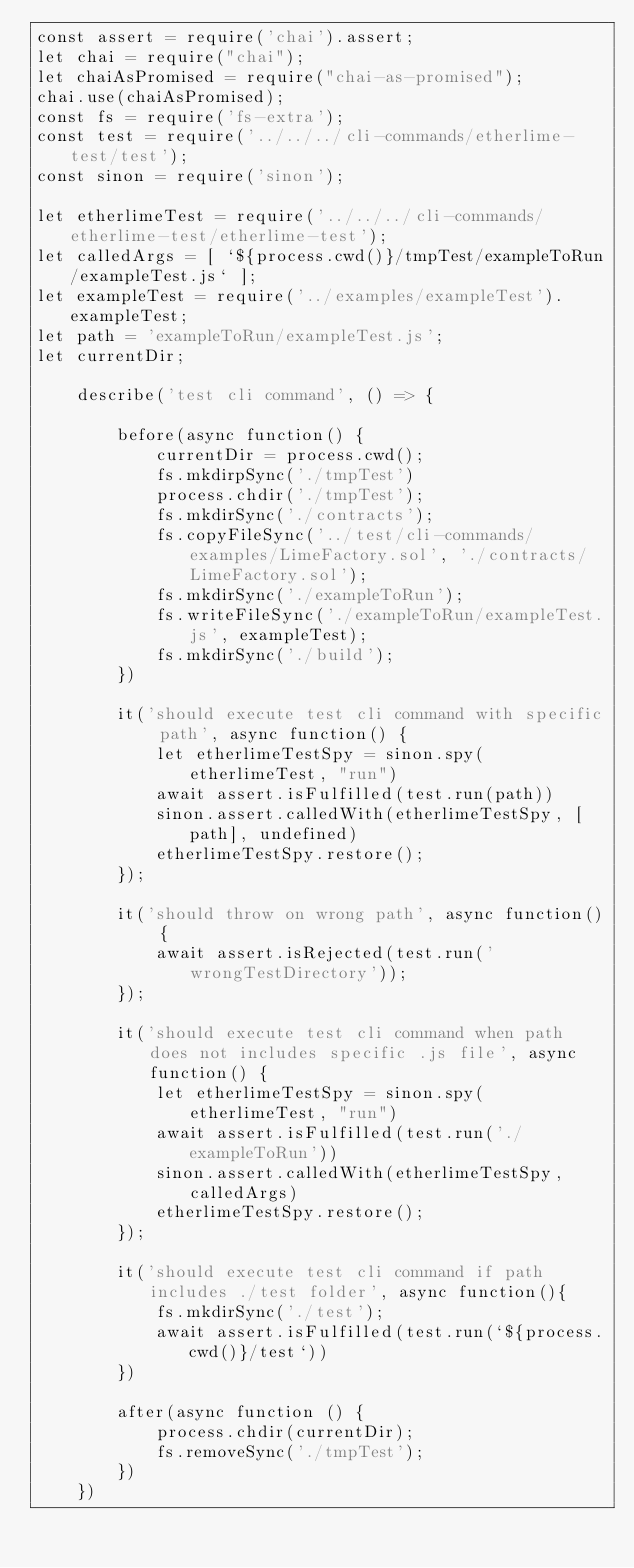<code> <loc_0><loc_0><loc_500><loc_500><_JavaScript_>const assert = require('chai').assert;
let chai = require("chai");
let chaiAsPromised = require("chai-as-promised");
chai.use(chaiAsPromised);
const fs = require('fs-extra');
const test = require('../../../cli-commands/etherlime-test/test');
const sinon = require('sinon');

let etherlimeTest = require('../../../cli-commands/etherlime-test/etherlime-test');
let calledArgs = [ `${process.cwd()}/tmpTest/exampleToRun/exampleTest.js` ];
let exampleTest = require('../examples/exampleTest').exampleTest;
let path = 'exampleToRun/exampleTest.js';
let currentDir;

    describe('test cli command', () => {

        before(async function() {
            currentDir = process.cwd();
            fs.mkdirpSync('./tmpTest')
            process.chdir('./tmpTest');
            fs.mkdirSync('./contracts');
            fs.copyFileSync('../test/cli-commands/examples/LimeFactory.sol', './contracts/LimeFactory.sol');
            fs.mkdirSync('./exampleToRun');
            fs.writeFileSync('./exampleToRun/exampleTest.js', exampleTest);
            fs.mkdirSync('./build');
        })
    
        it('should execute test cli command with specific path', async function() {
            let etherlimeTestSpy = sinon.spy(etherlimeTest, "run")
            await assert.isFulfilled(test.run(path))
            sinon.assert.calledWith(etherlimeTestSpy, [path], undefined)
            etherlimeTestSpy.restore();
        });
    
        it('should throw on wrong path', async function() {
            await assert.isRejected(test.run('wrongTestDirectory'));  
        });
    
        it('should execute test cli command when path does not includes specific .js file', async function() {
            let etherlimeTestSpy = sinon.spy(etherlimeTest, "run")
            await assert.isFulfilled(test.run('./exampleToRun'))
            sinon.assert.calledWith(etherlimeTestSpy, calledArgs)
            etherlimeTestSpy.restore();
        });

        it('should execute test cli command if path includes ./test folder', async function(){
            fs.mkdirSync('./test');
            await assert.isFulfilled(test.run(`${process.cwd()}/test`))
        })
    
        after(async function () {
            process.chdir(currentDir);
            fs.removeSync('./tmpTest');
        })
    })</code> 